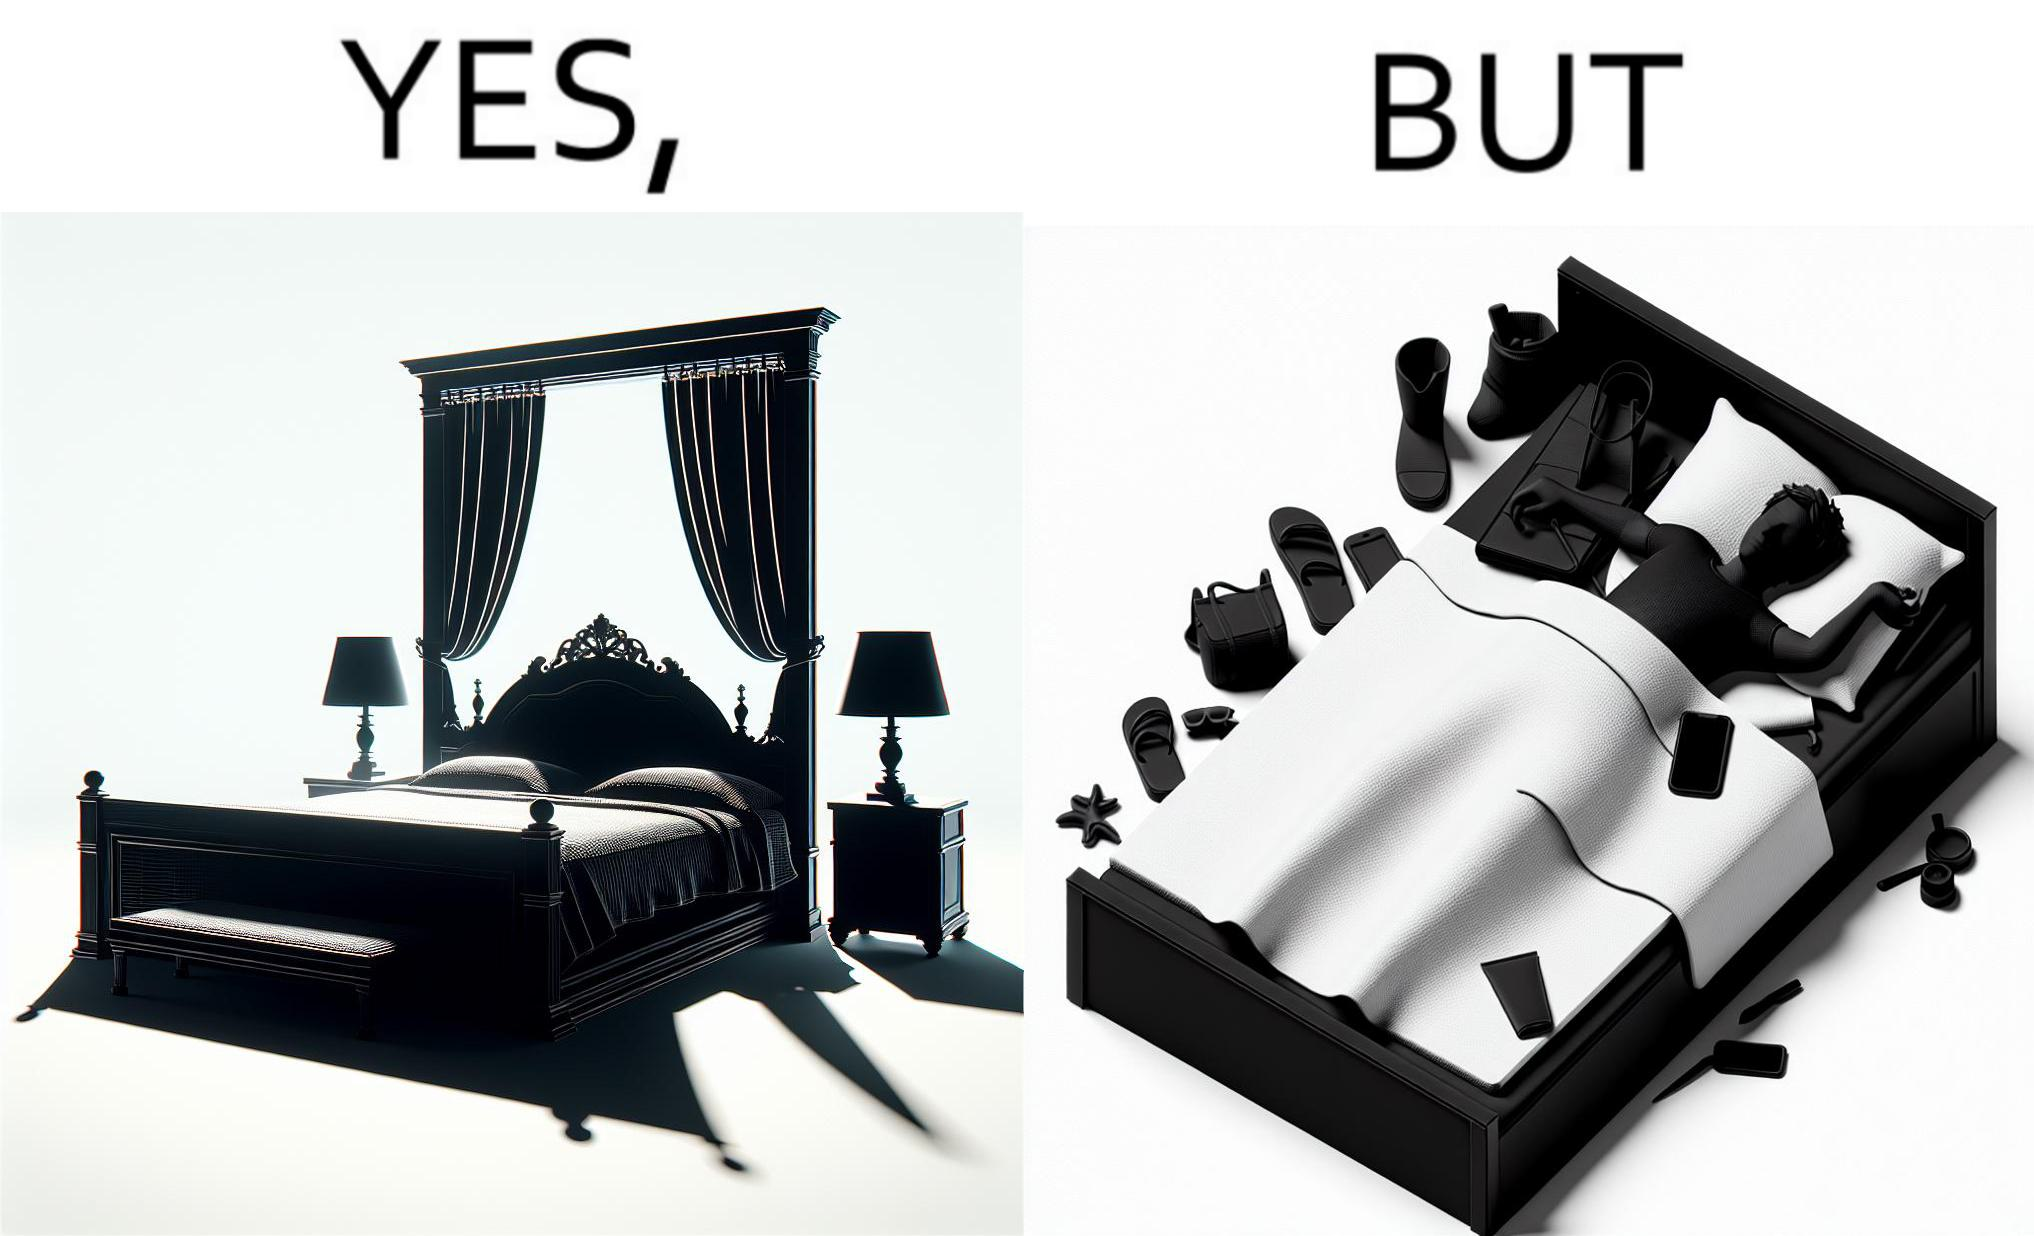Explain the humor or irony in this image. Although the person has purchased a king size bed, but only less than half of the space is used by the person for sleeping. 